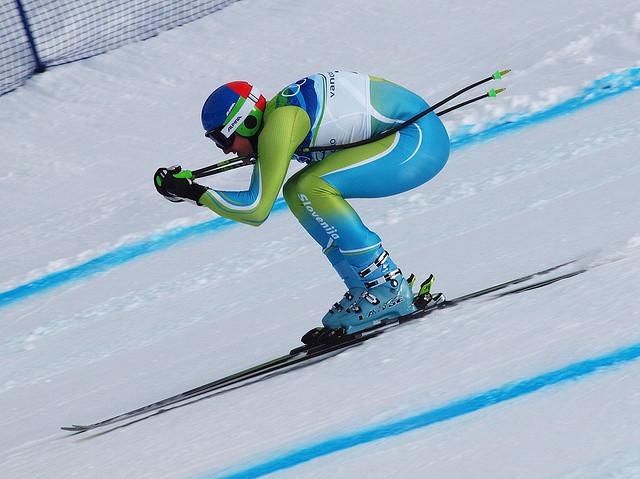What is the man holding in his hands?
Write a very short answer. Ski poles. Is this skier going fast?
Answer briefly. Yes. Is the skier going uphill?
Write a very short answer. No. 